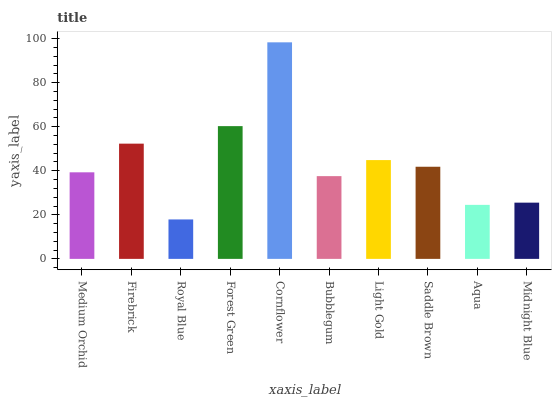Is Firebrick the minimum?
Answer yes or no. No. Is Firebrick the maximum?
Answer yes or no. No. Is Firebrick greater than Medium Orchid?
Answer yes or no. Yes. Is Medium Orchid less than Firebrick?
Answer yes or no. Yes. Is Medium Orchid greater than Firebrick?
Answer yes or no. No. Is Firebrick less than Medium Orchid?
Answer yes or no. No. Is Saddle Brown the high median?
Answer yes or no. Yes. Is Medium Orchid the low median?
Answer yes or no. Yes. Is Light Gold the high median?
Answer yes or no. No. Is Forest Green the low median?
Answer yes or no. No. 